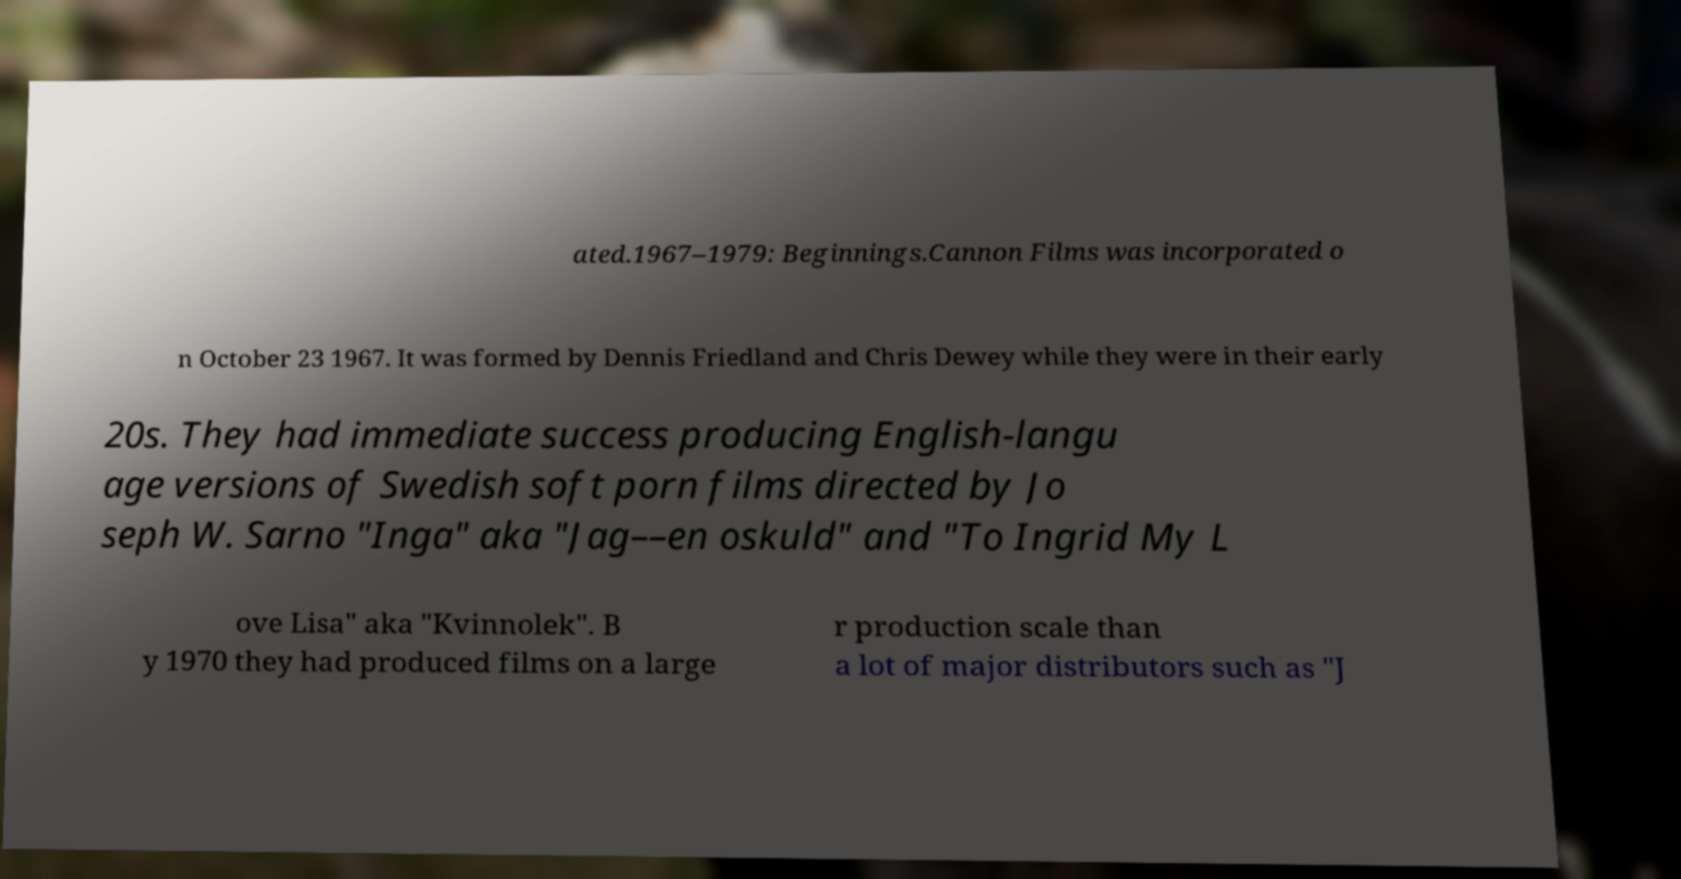There's text embedded in this image that I need extracted. Can you transcribe it verbatim? ated.1967–1979: Beginnings.Cannon Films was incorporated o n October 23 1967. It was formed by Dennis Friedland and Chris Dewey while they were in their early 20s. They had immediate success producing English-langu age versions of Swedish soft porn films directed by Jo seph W. Sarno "Inga" aka "Jag––en oskuld" and "To Ingrid My L ove Lisa" aka "Kvinnolek". B y 1970 they had produced films on a large r production scale than a lot of major distributors such as "J 